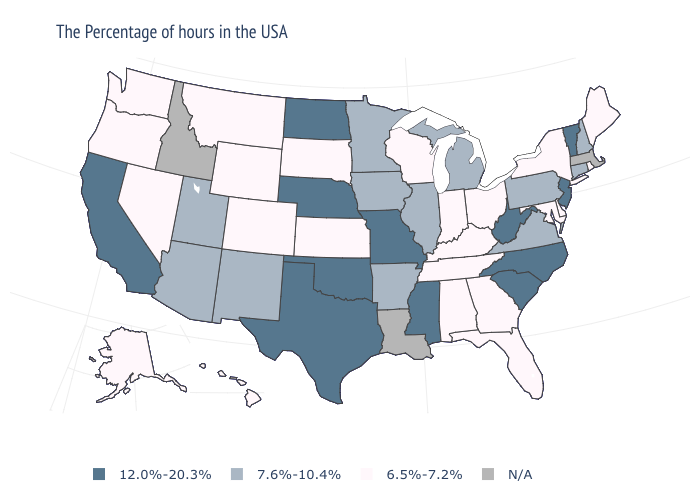Does the first symbol in the legend represent the smallest category?
Write a very short answer. No. What is the value of North Carolina?
Concise answer only. 12.0%-20.3%. What is the lowest value in states that border Oklahoma?
Keep it brief. 6.5%-7.2%. What is the highest value in the USA?
Write a very short answer. 12.0%-20.3%. What is the value of Alabama?
Answer briefly. 6.5%-7.2%. Does North Carolina have the highest value in the USA?
Give a very brief answer. Yes. Name the states that have a value in the range 6.5%-7.2%?
Short answer required. Maine, Rhode Island, New York, Delaware, Maryland, Ohio, Florida, Georgia, Kentucky, Indiana, Alabama, Tennessee, Wisconsin, Kansas, South Dakota, Wyoming, Colorado, Montana, Nevada, Washington, Oregon, Alaska, Hawaii. Among the states that border Nebraska , which have the lowest value?
Give a very brief answer. Kansas, South Dakota, Wyoming, Colorado. Which states have the lowest value in the USA?
Quick response, please. Maine, Rhode Island, New York, Delaware, Maryland, Ohio, Florida, Georgia, Kentucky, Indiana, Alabama, Tennessee, Wisconsin, Kansas, South Dakota, Wyoming, Colorado, Montana, Nevada, Washington, Oregon, Alaska, Hawaii. Name the states that have a value in the range 6.5%-7.2%?
Short answer required. Maine, Rhode Island, New York, Delaware, Maryland, Ohio, Florida, Georgia, Kentucky, Indiana, Alabama, Tennessee, Wisconsin, Kansas, South Dakota, Wyoming, Colorado, Montana, Nevada, Washington, Oregon, Alaska, Hawaii. Name the states that have a value in the range 12.0%-20.3%?
Write a very short answer. Vermont, New Jersey, North Carolina, South Carolina, West Virginia, Mississippi, Missouri, Nebraska, Oklahoma, Texas, North Dakota, California. What is the lowest value in the USA?
Concise answer only. 6.5%-7.2%. Does Nebraska have the highest value in the MidWest?
Short answer required. Yes. Name the states that have a value in the range 12.0%-20.3%?
Quick response, please. Vermont, New Jersey, North Carolina, South Carolina, West Virginia, Mississippi, Missouri, Nebraska, Oklahoma, Texas, North Dakota, California. 